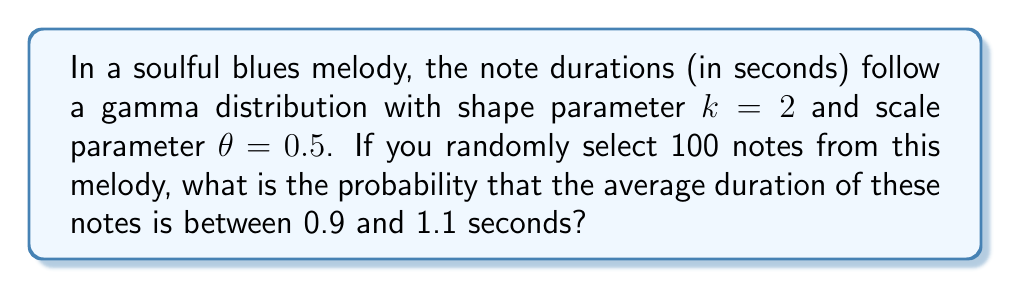Teach me how to tackle this problem. Let's approach this step-by-step:

1) The gamma distribution has a mean of $\mu = k\theta = 2 \cdot 0.5 = 1$ second and a variance of $\sigma^2 = k\theta^2 = 2 \cdot 0.5^2 = 0.5$ seconds².

2) When we take the average of 100 independent samples from this distribution, the Central Limit Theorem tells us that this average will be approximately normally distributed.

3) The mean of this normal distribution will be the same as the original distribution: $\mu_{\bar{X}} = 1$ second.

4) The variance of the sampling distribution of the mean is given by:
   $$\sigma_{\bar{X}}^2 = \frac{\sigma^2}{n} = \frac{0.5}{100} = 0.005$$

   So the standard deviation is $\sigma_{\bar{X}} = \sqrt{0.005} = 0.0707$ seconds.

5) We want to find $P(0.9 < \bar{X} < 1.1)$. To use the standard normal distribution, we need to standardize these bounds:

   $$z_1 = \frac{0.9 - 1}{0.0707} = -1.41$$
   $$z_2 = \frac{1.1 - 1}{0.0707} = 1.41$$

6) Now we can use the standard normal distribution to calculate:

   $$P(-1.41 < Z < 1.41) = \Phi(1.41) - \Phi(-1.41)$$

   where $\Phi$ is the cumulative distribution function of the standard normal distribution.

7) Using a standard normal table or calculator:

   $$\Phi(1.41) = 0.9207$$
   $$\Phi(-1.41) = 1 - 0.9207 = 0.0793$$

8) Therefore, the probability is:

   $$0.9207 - 0.0793 = 0.8414$$
Answer: 0.8414 